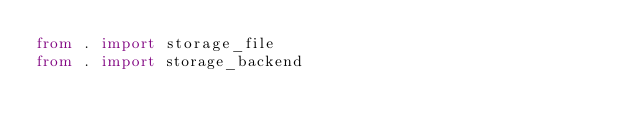Convert code to text. <code><loc_0><loc_0><loc_500><loc_500><_Python_>from . import storage_file
from . import storage_backend
</code> 